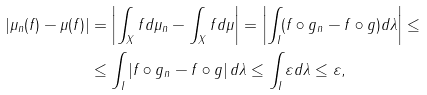<formula> <loc_0><loc_0><loc_500><loc_500>| \mu _ { n } ( f ) - \mu ( f ) | & = \left | \int _ { X } f d \mu _ { n } - \int _ { X } f d \mu \right | = \left | \int _ { I } ( f \circ g _ { n } - f \circ g ) d \lambda \right | \leq \\ & \leq \int _ { I } \left | f \circ g _ { n } - f \circ g \right | d \lambda \leq \int _ { I } \varepsilon d \lambda \leq \varepsilon ,</formula> 